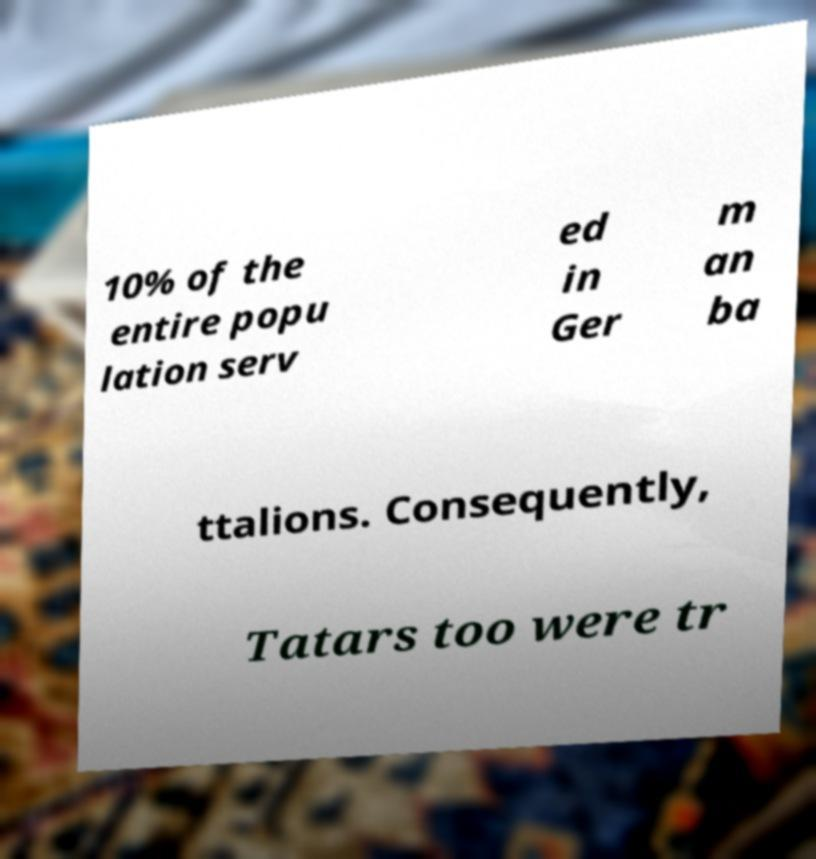Please read and relay the text visible in this image. What does it say? 10% of the entire popu lation serv ed in Ger m an ba ttalions. Consequently, Tatars too were tr 